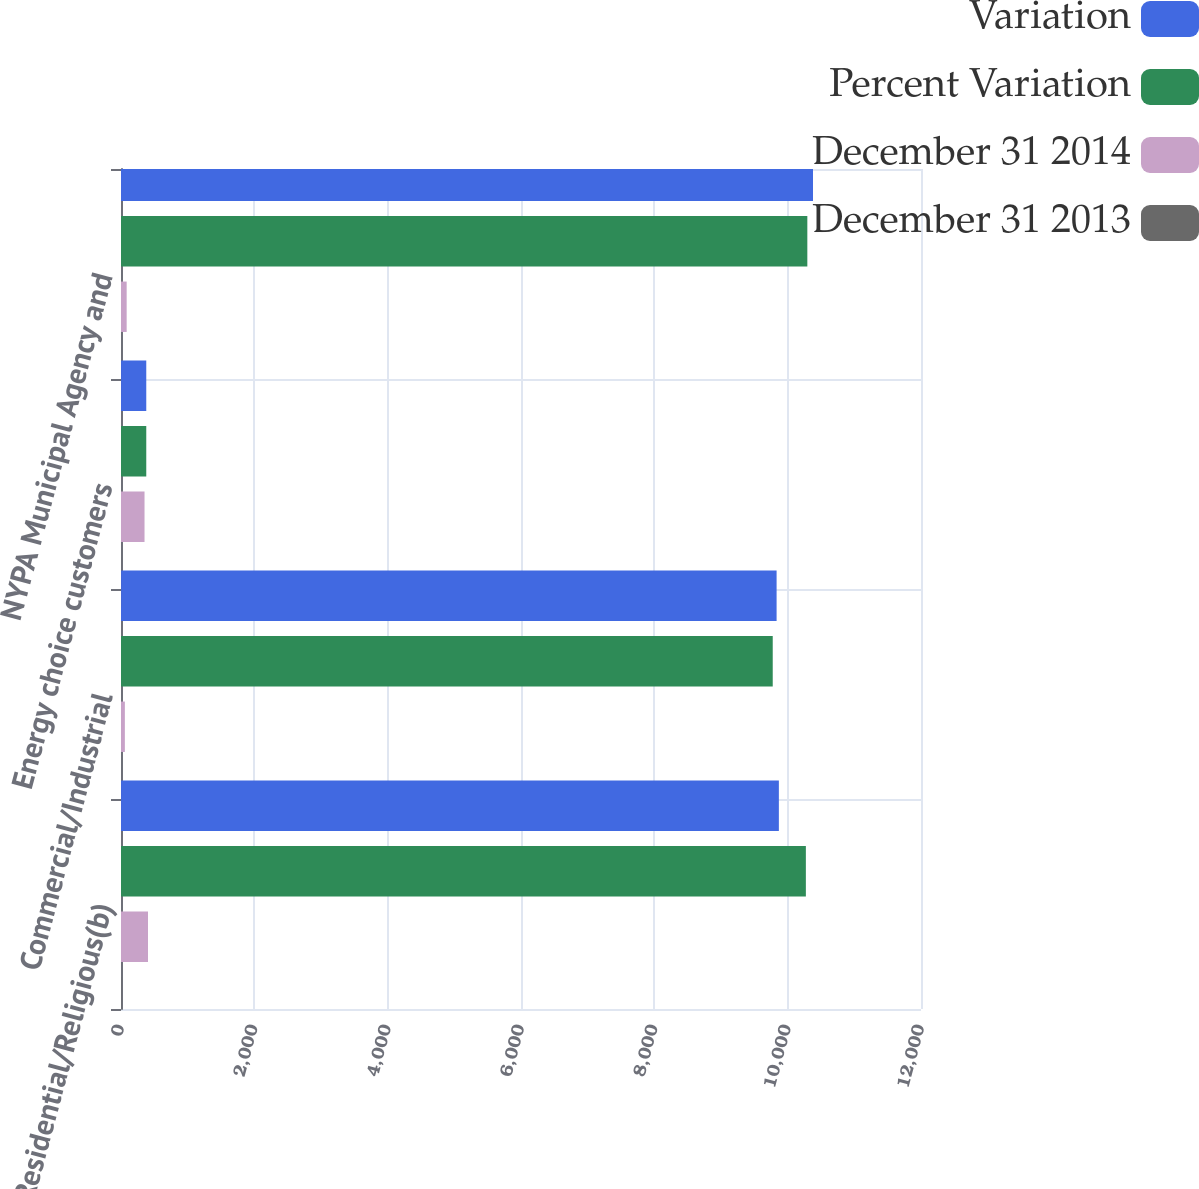<chart> <loc_0><loc_0><loc_500><loc_500><stacked_bar_chart><ecel><fcel>Residential/Religious(b)<fcel>Commercial/Industrial<fcel>Energy choice customers<fcel>NYPA Municipal Agency and<nl><fcel>Variation<fcel>9868<fcel>9834<fcel>379<fcel>10380<nl><fcel>Percent Variation<fcel>10273<fcel>9776<fcel>379<fcel>10295<nl><fcel>December 31 2014<fcel>405<fcel>58<fcel>353<fcel>85<nl><fcel>December 31 2013<fcel>3.9<fcel>0.6<fcel>1.3<fcel>0.8<nl></chart> 